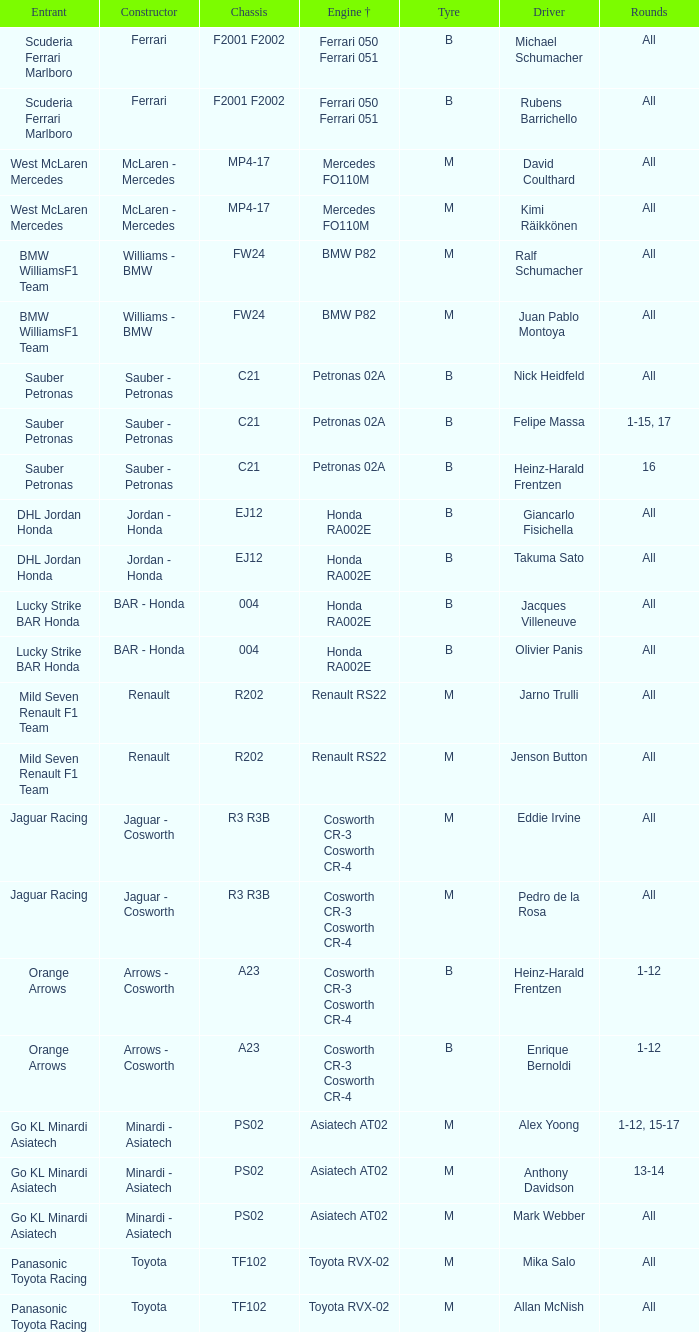Who is the driver when the engine is mercedes fo110m? David Coulthard, Kimi Räikkönen. 